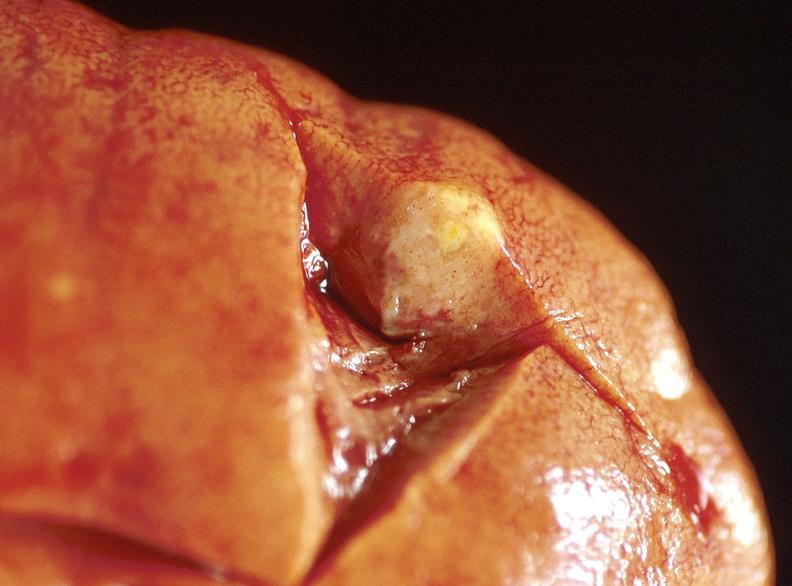does obvious metastatic lesion 44yobfadenocarcinoma of lung giant cell type show kidney, metastatic lung carcinoma?
Answer the question using a single word or phrase. No 